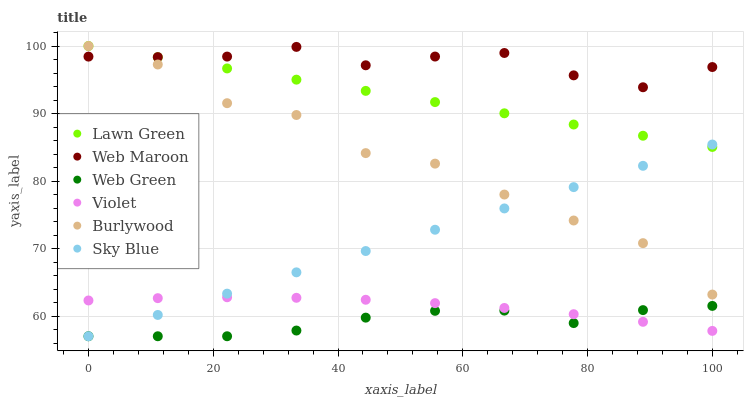Does Web Green have the minimum area under the curve?
Answer yes or no. Yes. Does Web Maroon have the maximum area under the curve?
Answer yes or no. Yes. Does Burlywood have the minimum area under the curve?
Answer yes or no. No. Does Burlywood have the maximum area under the curve?
Answer yes or no. No. Is Sky Blue the smoothest?
Answer yes or no. Yes. Is Burlywood the roughest?
Answer yes or no. Yes. Is Web Maroon the smoothest?
Answer yes or no. No. Is Web Maroon the roughest?
Answer yes or no. No. Does Web Green have the lowest value?
Answer yes or no. Yes. Does Burlywood have the lowest value?
Answer yes or no. No. Does Burlywood have the highest value?
Answer yes or no. Yes. Does Web Maroon have the highest value?
Answer yes or no. No. Is Violet less than Burlywood?
Answer yes or no. Yes. Is Web Maroon greater than Sky Blue?
Answer yes or no. Yes. Does Burlywood intersect Web Maroon?
Answer yes or no. Yes. Is Burlywood less than Web Maroon?
Answer yes or no. No. Is Burlywood greater than Web Maroon?
Answer yes or no. No. Does Violet intersect Burlywood?
Answer yes or no. No. 